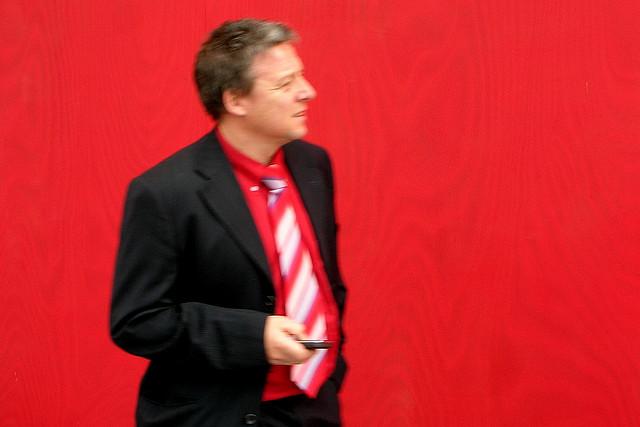Does the red shirt blend with parts of the tie?
Quick response, please. Yes. What color is the guy's shirt?
Keep it brief. Red. Who is this?
Quick response, please. Man. Is this a middle aged man?
Keep it brief. Yes. Is this man wearing glasses?
Short answer required. No. What color jacket is the man wearing?
Answer briefly. Black. 